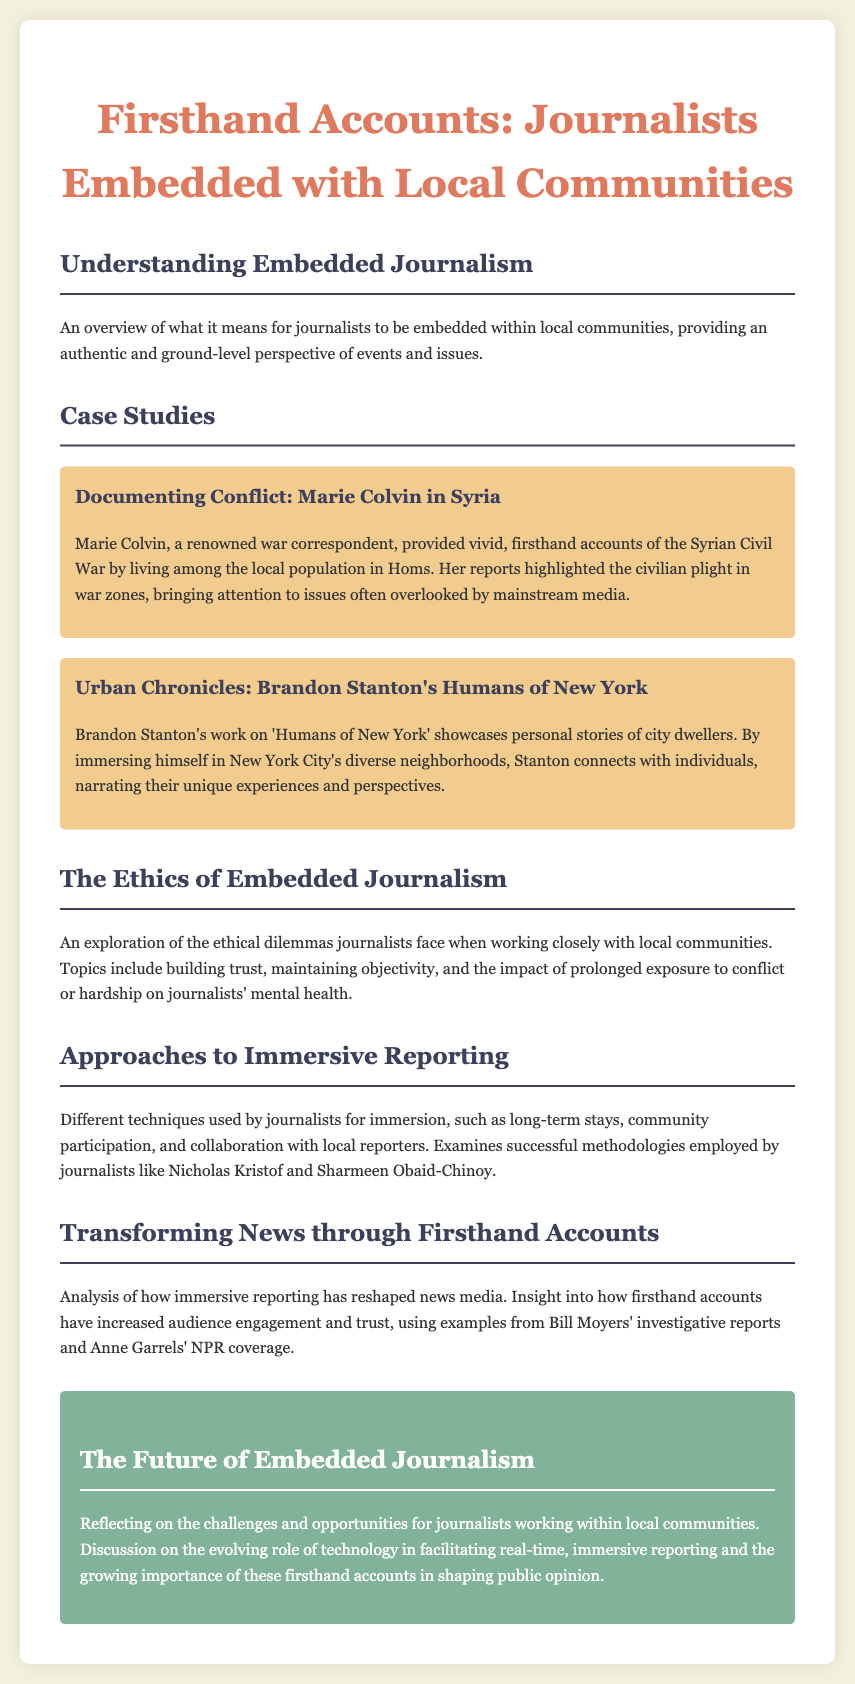What is the title of the document? The title is stated prominently at the top of the document, summarizing its focus on journalist engagement with communities.
Answer: Firsthand Accounts: Journalists Embedded with Local Communities Who is the renowned war correspondent mentioned? The document specifically names a notable figure who reported from within conflict zones, showcasing her influential work.
Answer: Marie Colvin What city is Brandon Stanton associated with in his work? The section on Brandon Stanton points out the specific location where he conducts his immersive storytelling.
Answer: New York City What is a key focus of embedded journalism ethics? The document lists important considerations for journalists when deeply involved with communities, addressing ethical responsibilities.
Answer: Building trust Which journalist's investigative reports are referenced as transformative? The analysis in the document credits a well-known journalist with impactful investigative storytelling that changed the media landscape.
Answer: Bill Moyers What is discussed in the conclusion regarding the future of embedded journalism? The conclusion summarizes anticipated trends and challenges for journalists in the context of community engagement going forward.
Answer: Challenges and opportunities 